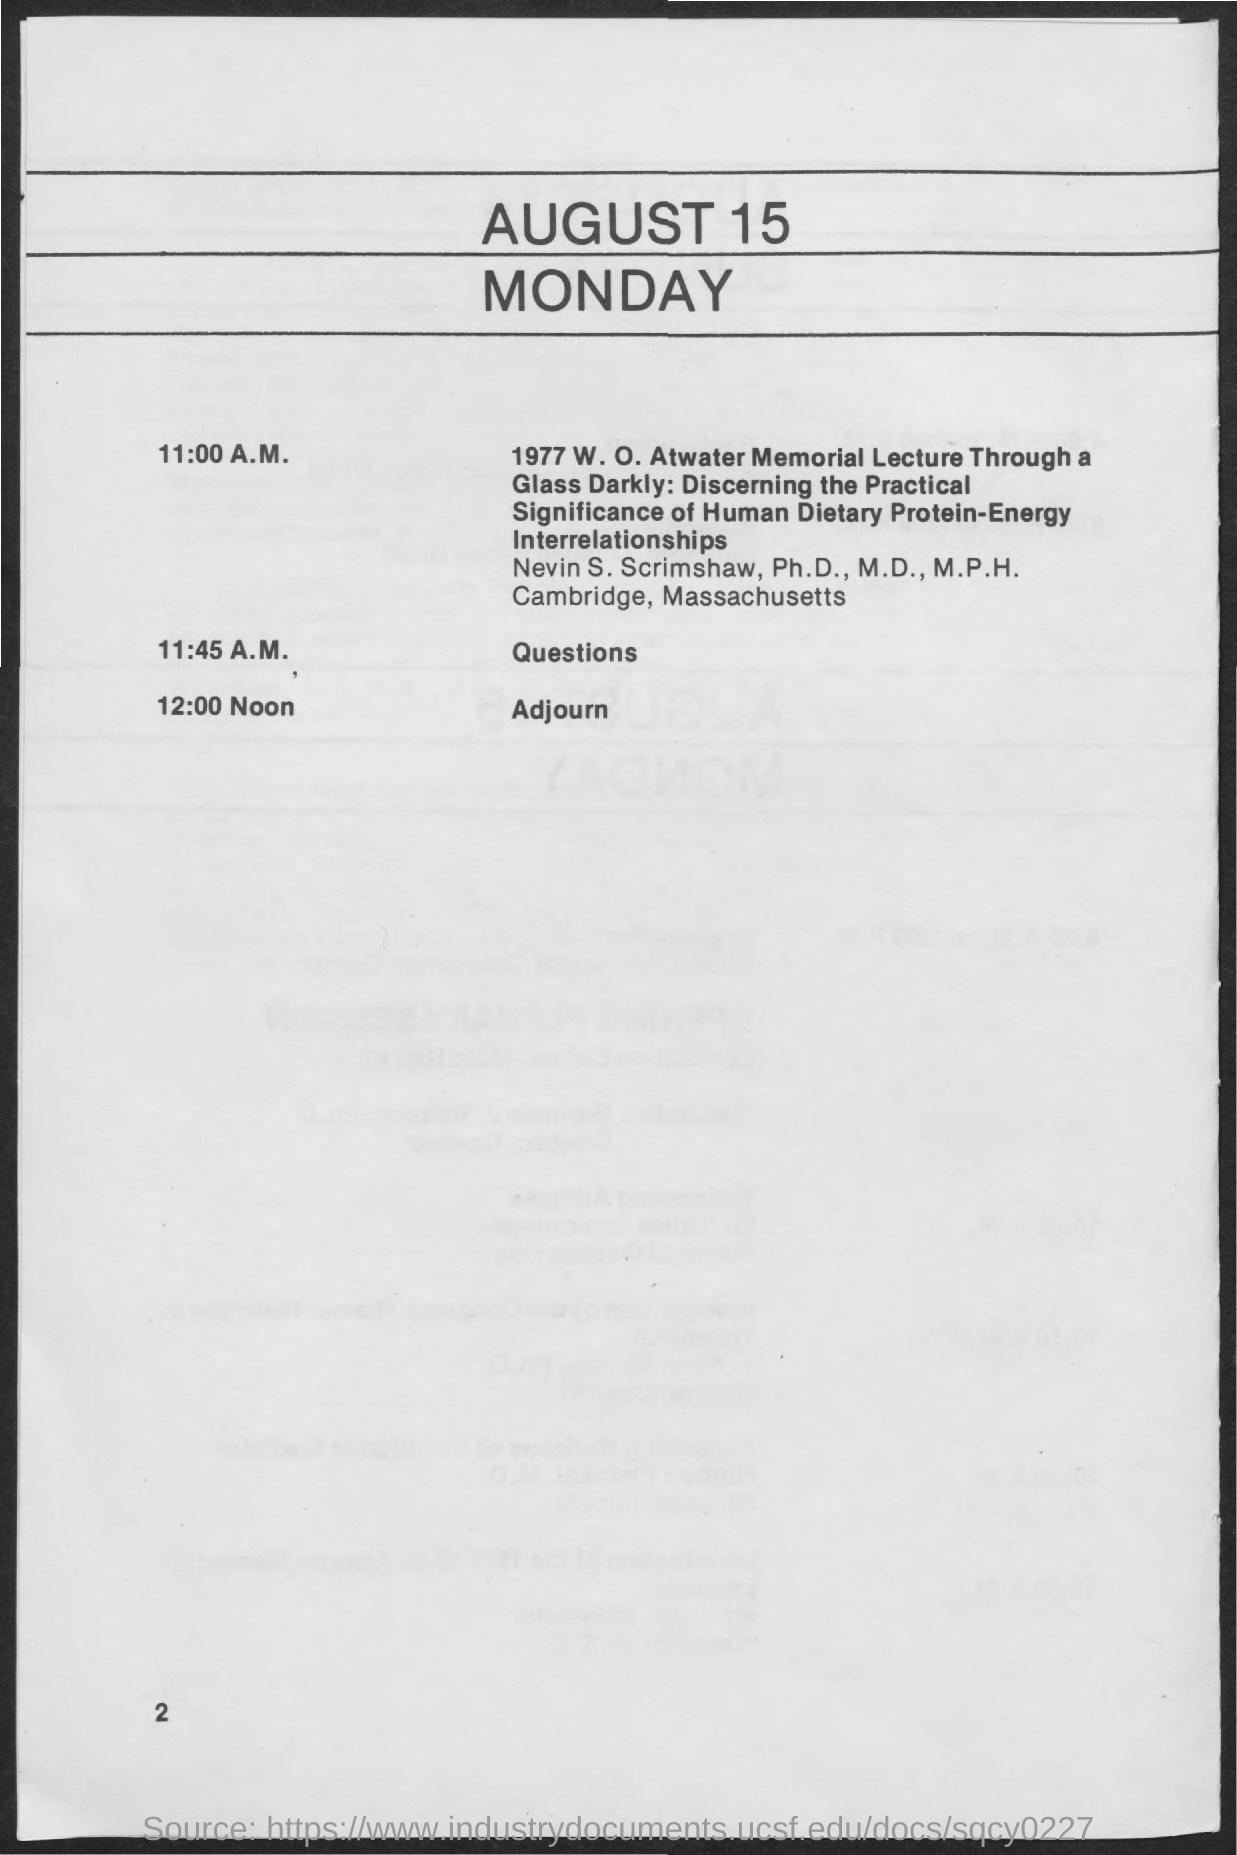What is the date on the document?
Your response must be concise. August 15. When is the Adjourn?
Give a very brief answer. 12:00 Noon. 